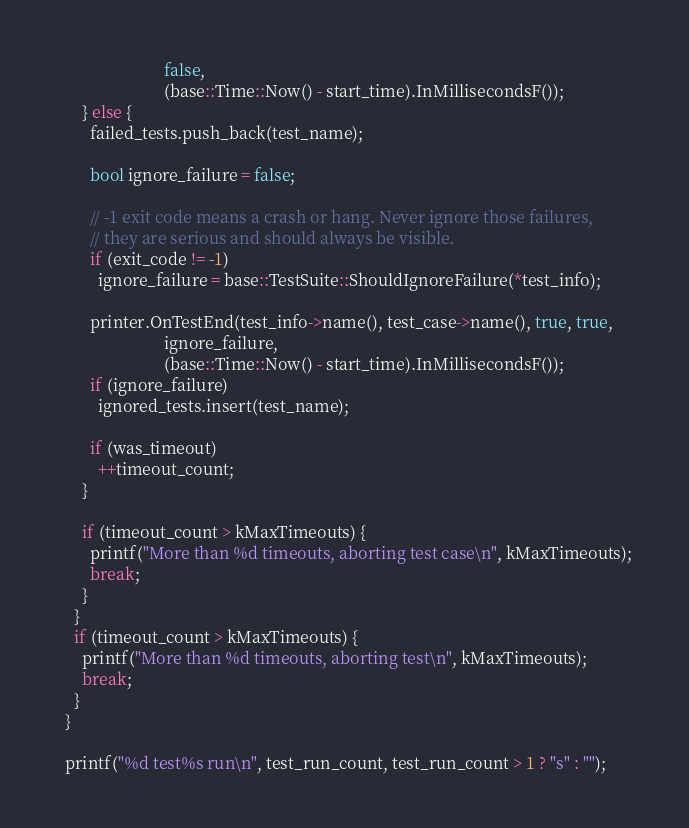<code> <loc_0><loc_0><loc_500><loc_500><_C++_>                          false,
                          (base::Time::Now() - start_time).InMillisecondsF());
      } else {
        failed_tests.push_back(test_name);

        bool ignore_failure = false;

        // -1 exit code means a crash or hang. Never ignore those failures,
        // they are serious and should always be visible.
        if (exit_code != -1)
          ignore_failure = base::TestSuite::ShouldIgnoreFailure(*test_info);

        printer.OnTestEnd(test_info->name(), test_case->name(), true, true,
                          ignore_failure,
                          (base::Time::Now() - start_time).InMillisecondsF());
        if (ignore_failure)
          ignored_tests.insert(test_name);

        if (was_timeout)
          ++timeout_count;
      }

      if (timeout_count > kMaxTimeouts) {
        printf("More than %d timeouts, aborting test case\n", kMaxTimeouts);
        break;
      }
    }
    if (timeout_count > kMaxTimeouts) {
      printf("More than %d timeouts, aborting test\n", kMaxTimeouts);
      break;
    }
  }

  printf("%d test%s run\n", test_run_count, test_run_count > 1 ? "s" : "");</code> 